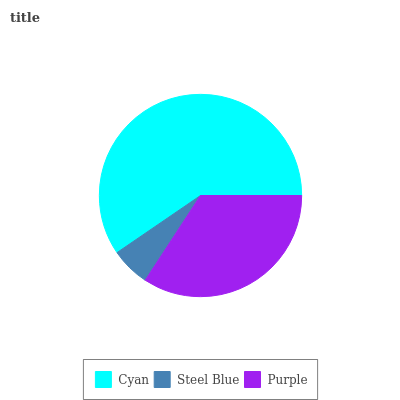Is Steel Blue the minimum?
Answer yes or no. Yes. Is Cyan the maximum?
Answer yes or no. Yes. Is Purple the minimum?
Answer yes or no. No. Is Purple the maximum?
Answer yes or no. No. Is Purple greater than Steel Blue?
Answer yes or no. Yes. Is Steel Blue less than Purple?
Answer yes or no. Yes. Is Steel Blue greater than Purple?
Answer yes or no. No. Is Purple less than Steel Blue?
Answer yes or no. No. Is Purple the high median?
Answer yes or no. Yes. Is Purple the low median?
Answer yes or no. Yes. Is Steel Blue the high median?
Answer yes or no. No. Is Cyan the low median?
Answer yes or no. No. 